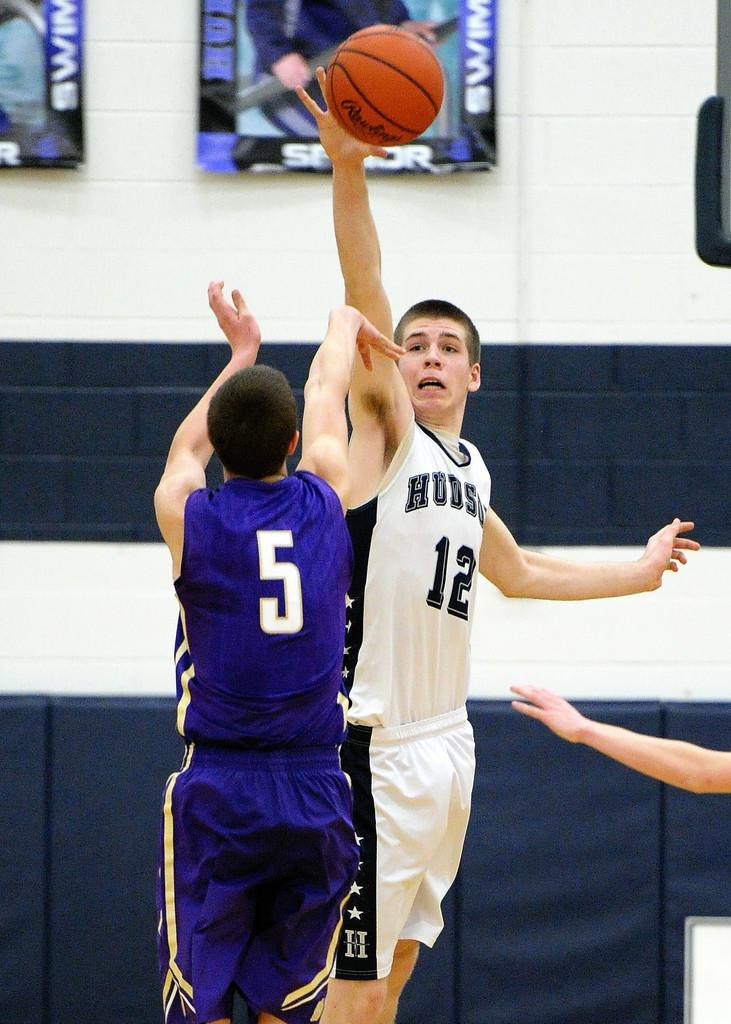<image>
Offer a succinct explanation of the picture presented. A boy wearing a Hudson jersey shooting over another boy. 